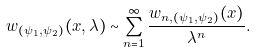<formula> <loc_0><loc_0><loc_500><loc_500>w _ { ( \psi _ { 1 } , \psi _ { 2 } ) } ( x , \lambda ) \sim \sum _ { n = 1 } ^ { \infty } \frac { w _ { n , ( \psi _ { 1 } , \psi _ { 2 } ) } ( x ) } { \lambda ^ { n } } .</formula> 